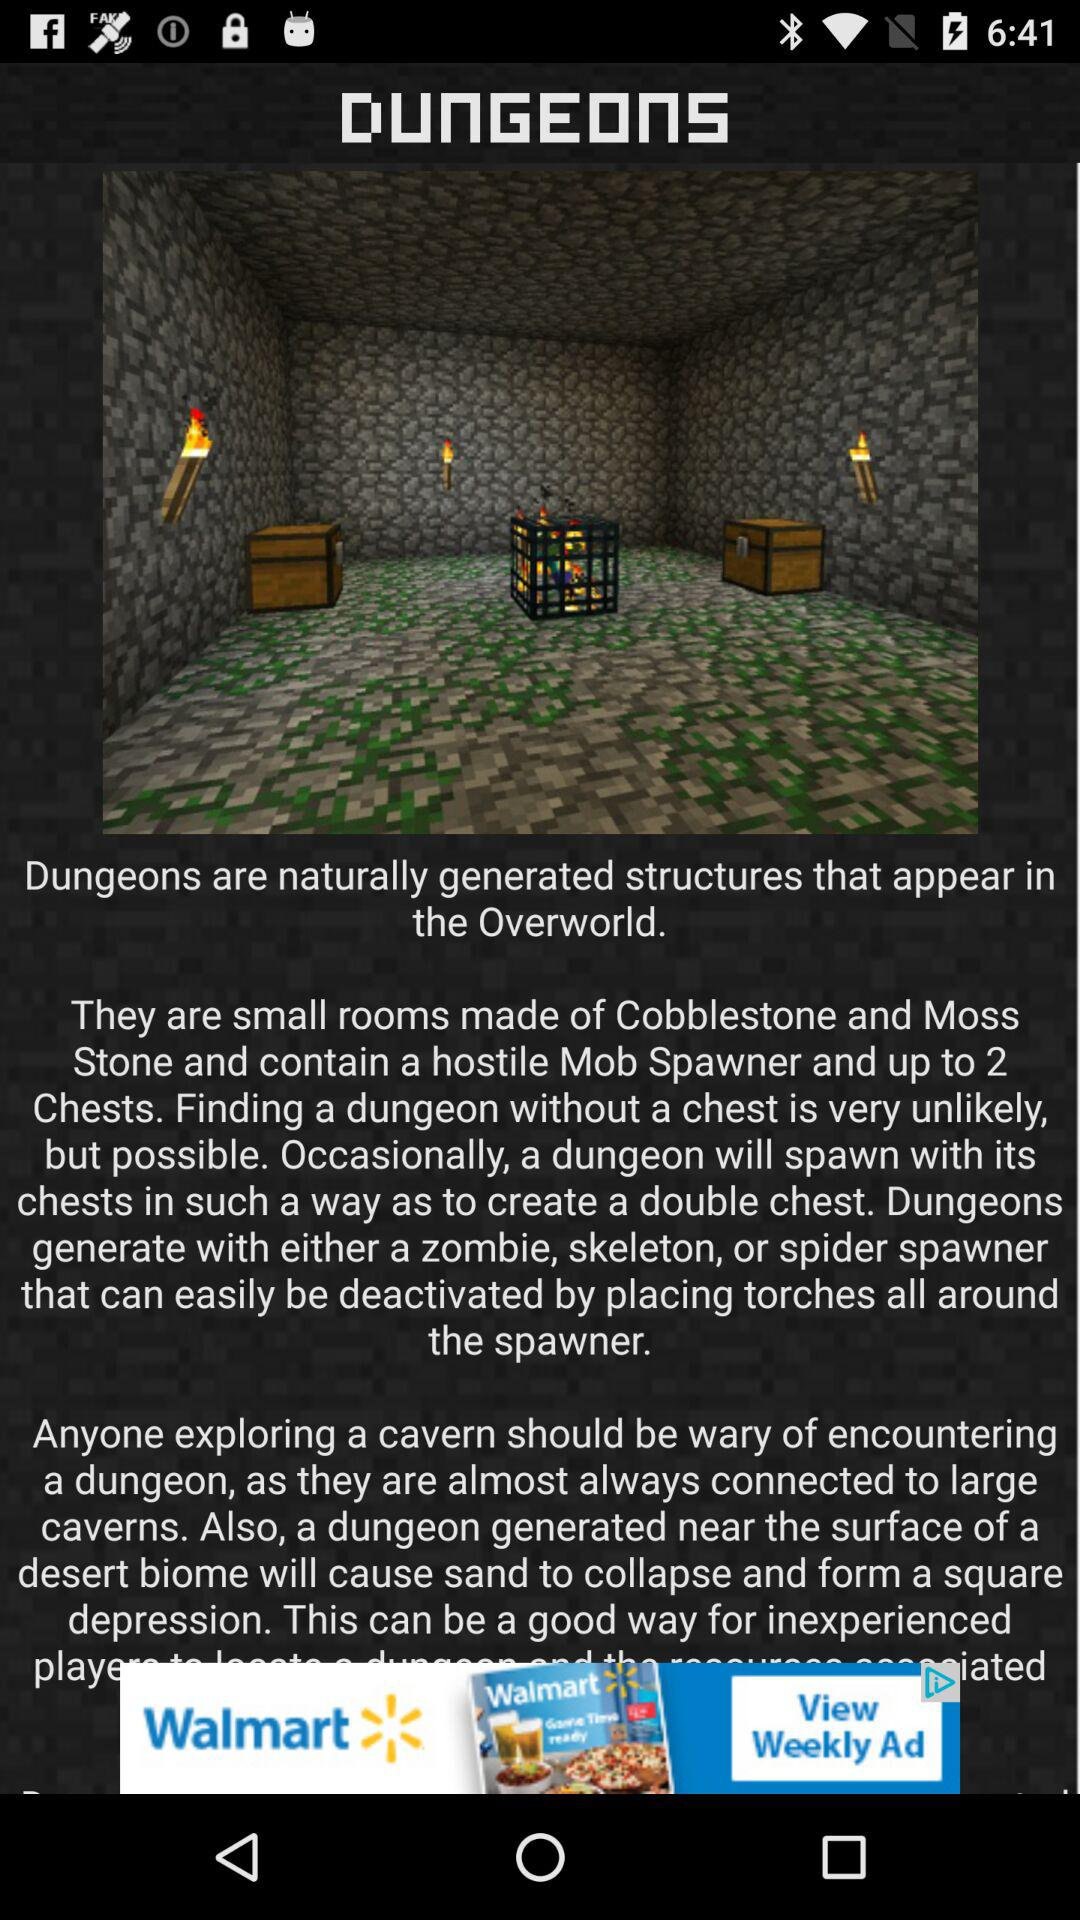What is the name of the article? The name of the article is dungeons. 